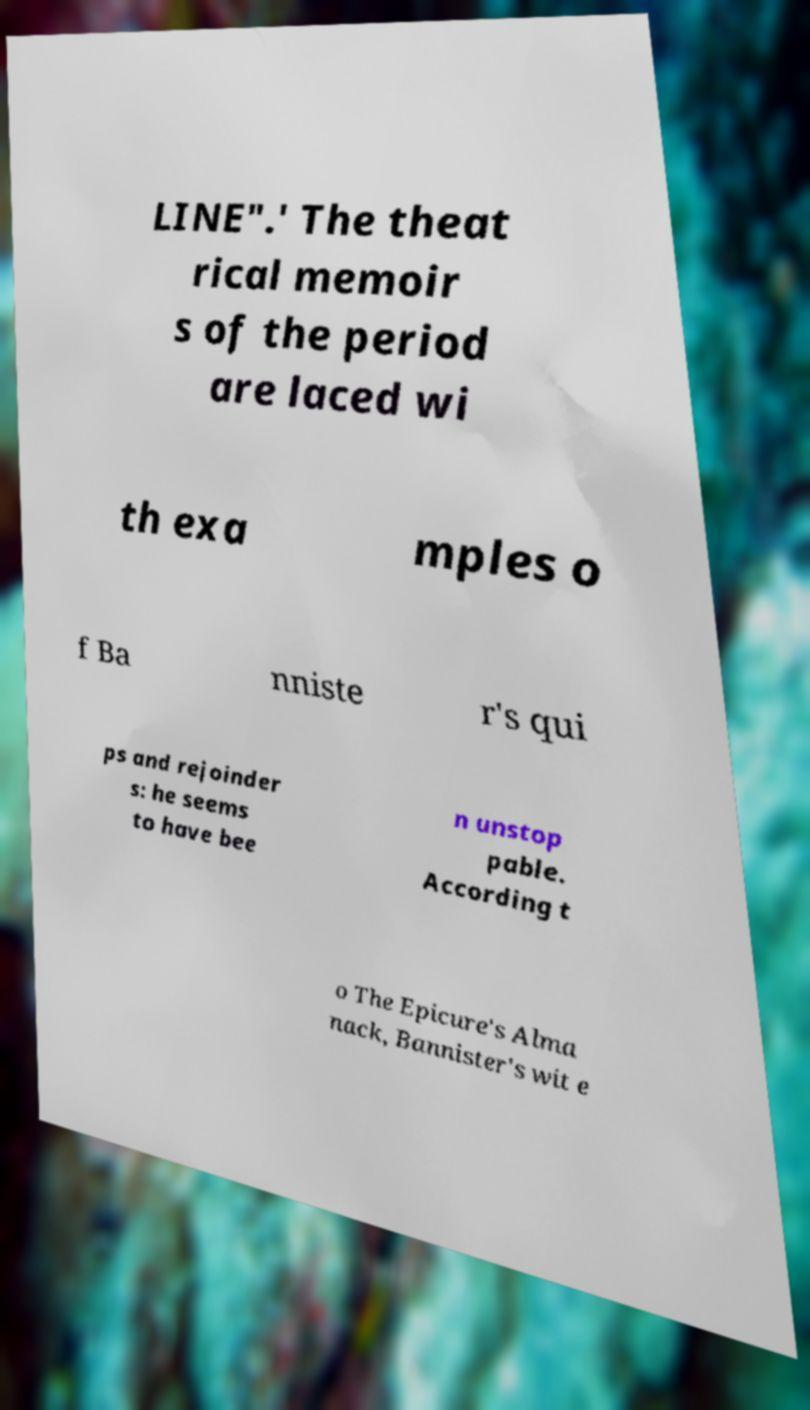Can you read and provide the text displayed in the image?This photo seems to have some interesting text. Can you extract and type it out for me? LINE".' The theat rical memoir s of the period are laced wi th exa mples o f Ba nniste r's qui ps and rejoinder s: he seems to have bee n unstop pable. According t o The Epicure's Alma nack, Bannister's wit e 